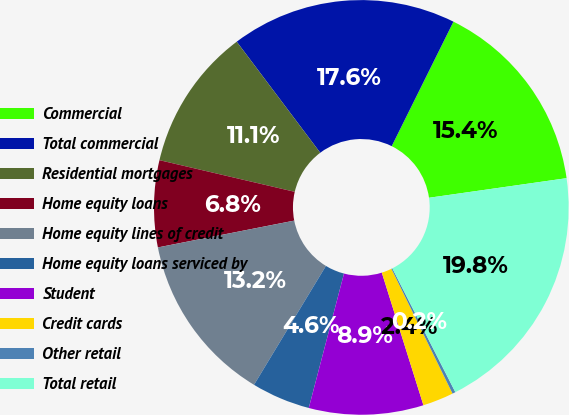<chart> <loc_0><loc_0><loc_500><loc_500><pie_chart><fcel>Commercial<fcel>Total commercial<fcel>Residential mortgages<fcel>Home equity loans<fcel>Home equity lines of credit<fcel>Home equity loans serviced by<fcel>Student<fcel>Credit cards<fcel>Other retail<fcel>Total retail<nl><fcel>15.42%<fcel>17.59%<fcel>11.08%<fcel>6.75%<fcel>13.25%<fcel>4.58%<fcel>8.92%<fcel>2.41%<fcel>0.24%<fcel>19.76%<nl></chart> 